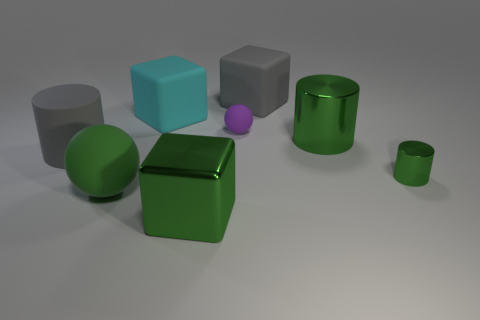Add 1 green blocks. How many objects exist? 9 Subtract all green cylinders. How many cylinders are left? 1 Subtract all cylinders. How many objects are left? 5 Subtract all cyan blocks. How many blocks are left? 2 Subtract 1 blocks. How many blocks are left? 2 Subtract all gray balls. Subtract all brown cylinders. How many balls are left? 2 Subtract all purple cylinders. How many green balls are left? 1 Subtract all cyan rubber blocks. Subtract all green things. How many objects are left? 3 Add 4 small green metal things. How many small green metal things are left? 5 Add 5 rubber spheres. How many rubber spheres exist? 7 